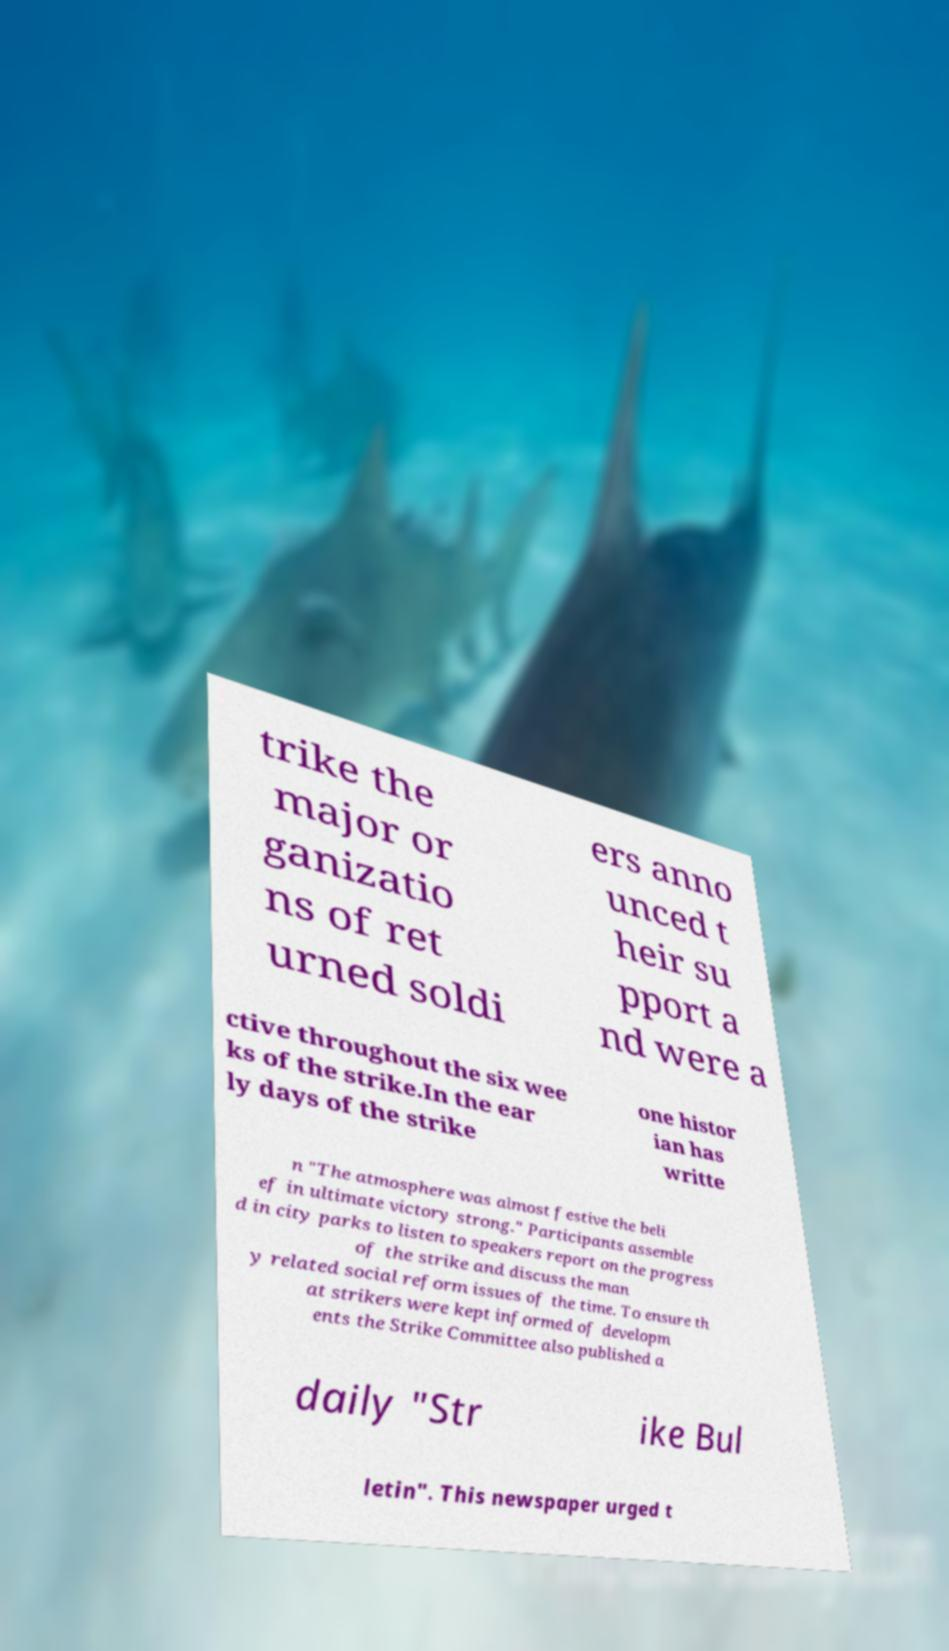I need the written content from this picture converted into text. Can you do that? trike the major or ganizatio ns of ret urned soldi ers anno unced t heir su pport a nd were a ctive throughout the six wee ks of the strike.In the ear ly days of the strike one histor ian has writte n "The atmosphere was almost festive the beli ef in ultimate victory strong." Participants assemble d in city parks to listen to speakers report on the progress of the strike and discuss the man y related social reform issues of the time. To ensure th at strikers were kept informed of developm ents the Strike Committee also published a daily "Str ike Bul letin". This newspaper urged t 